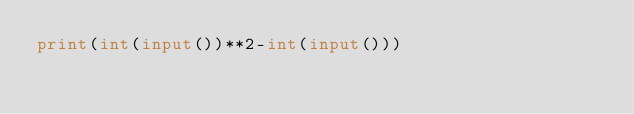Convert code to text. <code><loc_0><loc_0><loc_500><loc_500><_Python_>print(int(input())**2-int(input()))</code> 